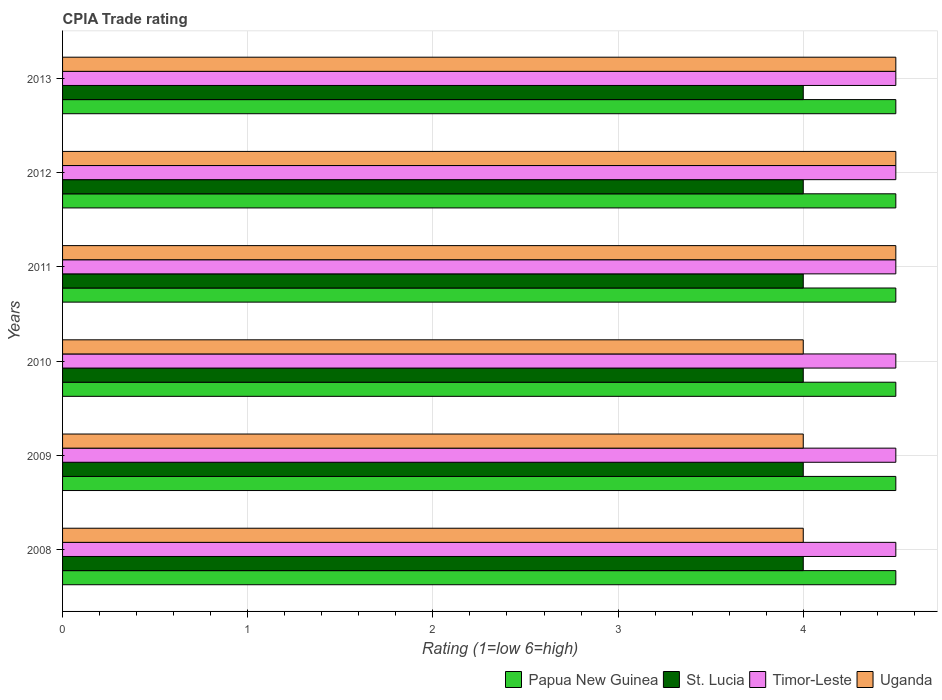How many groups of bars are there?
Give a very brief answer. 6. How many bars are there on the 3rd tick from the top?
Your answer should be very brief. 4. What is the CPIA rating in Papua New Guinea in 2012?
Provide a succinct answer. 4.5. Across all years, what is the maximum CPIA rating in Uganda?
Keep it short and to the point. 4.5. Across all years, what is the minimum CPIA rating in St. Lucia?
Make the answer very short. 4. In which year was the CPIA rating in Uganda maximum?
Provide a short and direct response. 2011. What is the total CPIA rating in St. Lucia in the graph?
Your answer should be very brief. 24. What is the difference between the CPIA rating in Uganda in 2010 and the CPIA rating in Timor-Leste in 2009?
Your answer should be compact. -0.5. What is the ratio of the CPIA rating in St. Lucia in 2011 to that in 2012?
Your response must be concise. 1. Is the CPIA rating in St. Lucia in 2010 less than that in 2011?
Ensure brevity in your answer.  No. Is the difference between the CPIA rating in St. Lucia in 2009 and 2011 greater than the difference between the CPIA rating in Timor-Leste in 2009 and 2011?
Provide a succinct answer. No. What is the difference between the highest and the second highest CPIA rating in St. Lucia?
Provide a short and direct response. 0. What is the difference between the highest and the lowest CPIA rating in Timor-Leste?
Ensure brevity in your answer.  0. Is it the case that in every year, the sum of the CPIA rating in Papua New Guinea and CPIA rating in Timor-Leste is greater than the sum of CPIA rating in Uganda and CPIA rating in St. Lucia?
Your answer should be compact. No. What does the 2nd bar from the top in 2011 represents?
Provide a short and direct response. Timor-Leste. What does the 2nd bar from the bottom in 2009 represents?
Your answer should be compact. St. Lucia. How many bars are there?
Offer a terse response. 24. What is the difference between two consecutive major ticks on the X-axis?
Provide a succinct answer. 1. Are the values on the major ticks of X-axis written in scientific E-notation?
Provide a succinct answer. No. Does the graph contain any zero values?
Your answer should be compact. No. Does the graph contain grids?
Your response must be concise. Yes. Where does the legend appear in the graph?
Keep it short and to the point. Bottom right. How many legend labels are there?
Keep it short and to the point. 4. How are the legend labels stacked?
Keep it short and to the point. Horizontal. What is the title of the graph?
Offer a very short reply. CPIA Trade rating. What is the Rating (1=low 6=high) in St. Lucia in 2008?
Make the answer very short. 4. What is the Rating (1=low 6=high) in Timor-Leste in 2008?
Provide a succinct answer. 4.5. What is the Rating (1=low 6=high) of Uganda in 2008?
Provide a short and direct response. 4. What is the Rating (1=low 6=high) in Timor-Leste in 2009?
Your response must be concise. 4.5. What is the Rating (1=low 6=high) in St. Lucia in 2010?
Your answer should be compact. 4. What is the Rating (1=low 6=high) in St. Lucia in 2011?
Your answer should be compact. 4. What is the Rating (1=low 6=high) in Uganda in 2011?
Give a very brief answer. 4.5. What is the Rating (1=low 6=high) of Papua New Guinea in 2013?
Offer a terse response. 4.5. What is the Rating (1=low 6=high) in Uganda in 2013?
Ensure brevity in your answer.  4.5. Across all years, what is the maximum Rating (1=low 6=high) in Papua New Guinea?
Your answer should be very brief. 4.5. Across all years, what is the maximum Rating (1=low 6=high) in St. Lucia?
Keep it short and to the point. 4. Across all years, what is the maximum Rating (1=low 6=high) of Uganda?
Ensure brevity in your answer.  4.5. Across all years, what is the minimum Rating (1=low 6=high) in Papua New Guinea?
Your answer should be very brief. 4.5. Across all years, what is the minimum Rating (1=low 6=high) in St. Lucia?
Your answer should be compact. 4. Across all years, what is the minimum Rating (1=low 6=high) in Uganda?
Your answer should be compact. 4. What is the total Rating (1=low 6=high) in Papua New Guinea in the graph?
Offer a very short reply. 27. What is the total Rating (1=low 6=high) of St. Lucia in the graph?
Make the answer very short. 24. What is the total Rating (1=low 6=high) of Timor-Leste in the graph?
Offer a terse response. 27. What is the difference between the Rating (1=low 6=high) in Papua New Guinea in 2008 and that in 2009?
Ensure brevity in your answer.  0. What is the difference between the Rating (1=low 6=high) in Timor-Leste in 2008 and that in 2009?
Make the answer very short. 0. What is the difference between the Rating (1=low 6=high) of Uganda in 2008 and that in 2009?
Your answer should be compact. 0. What is the difference between the Rating (1=low 6=high) in Timor-Leste in 2008 and that in 2010?
Give a very brief answer. 0. What is the difference between the Rating (1=low 6=high) of Uganda in 2008 and that in 2010?
Offer a very short reply. 0. What is the difference between the Rating (1=low 6=high) in Papua New Guinea in 2008 and that in 2011?
Offer a very short reply. 0. What is the difference between the Rating (1=low 6=high) of St. Lucia in 2008 and that in 2011?
Make the answer very short. 0. What is the difference between the Rating (1=low 6=high) in Uganda in 2008 and that in 2011?
Offer a very short reply. -0.5. What is the difference between the Rating (1=low 6=high) in Timor-Leste in 2008 and that in 2012?
Make the answer very short. 0. What is the difference between the Rating (1=low 6=high) of Uganda in 2008 and that in 2012?
Your answer should be compact. -0.5. What is the difference between the Rating (1=low 6=high) in Papua New Guinea in 2008 and that in 2013?
Provide a short and direct response. 0. What is the difference between the Rating (1=low 6=high) in St. Lucia in 2008 and that in 2013?
Offer a terse response. 0. What is the difference between the Rating (1=low 6=high) of Timor-Leste in 2008 and that in 2013?
Your answer should be compact. 0. What is the difference between the Rating (1=low 6=high) in Uganda in 2008 and that in 2013?
Provide a short and direct response. -0.5. What is the difference between the Rating (1=low 6=high) of Uganda in 2009 and that in 2010?
Offer a terse response. 0. What is the difference between the Rating (1=low 6=high) in Papua New Guinea in 2009 and that in 2012?
Keep it short and to the point. 0. What is the difference between the Rating (1=low 6=high) in St. Lucia in 2009 and that in 2012?
Keep it short and to the point. 0. What is the difference between the Rating (1=low 6=high) in Timor-Leste in 2009 and that in 2012?
Offer a terse response. 0. What is the difference between the Rating (1=low 6=high) of Uganda in 2009 and that in 2012?
Make the answer very short. -0.5. What is the difference between the Rating (1=low 6=high) in Papua New Guinea in 2009 and that in 2013?
Provide a short and direct response. 0. What is the difference between the Rating (1=low 6=high) of St. Lucia in 2009 and that in 2013?
Provide a short and direct response. 0. What is the difference between the Rating (1=low 6=high) of Timor-Leste in 2009 and that in 2013?
Provide a short and direct response. 0. What is the difference between the Rating (1=low 6=high) of Papua New Guinea in 2010 and that in 2011?
Ensure brevity in your answer.  0. What is the difference between the Rating (1=low 6=high) in Uganda in 2010 and that in 2012?
Your response must be concise. -0.5. What is the difference between the Rating (1=low 6=high) in St. Lucia in 2010 and that in 2013?
Your answer should be compact. 0. What is the difference between the Rating (1=low 6=high) in Uganda in 2010 and that in 2013?
Your answer should be compact. -0.5. What is the difference between the Rating (1=low 6=high) in Papua New Guinea in 2011 and that in 2012?
Your answer should be compact. 0. What is the difference between the Rating (1=low 6=high) of Timor-Leste in 2011 and that in 2012?
Make the answer very short. 0. What is the difference between the Rating (1=low 6=high) of Uganda in 2011 and that in 2012?
Ensure brevity in your answer.  0. What is the difference between the Rating (1=low 6=high) of St. Lucia in 2011 and that in 2013?
Provide a succinct answer. 0. What is the difference between the Rating (1=low 6=high) of Timor-Leste in 2011 and that in 2013?
Your response must be concise. 0. What is the difference between the Rating (1=low 6=high) of Uganda in 2011 and that in 2013?
Provide a succinct answer. 0. What is the difference between the Rating (1=low 6=high) in Timor-Leste in 2012 and that in 2013?
Offer a terse response. 0. What is the difference between the Rating (1=low 6=high) in Uganda in 2012 and that in 2013?
Your answer should be very brief. 0. What is the difference between the Rating (1=low 6=high) of Papua New Guinea in 2008 and the Rating (1=low 6=high) of Timor-Leste in 2009?
Give a very brief answer. 0. What is the difference between the Rating (1=low 6=high) of Papua New Guinea in 2008 and the Rating (1=low 6=high) of Uganda in 2009?
Provide a short and direct response. 0.5. What is the difference between the Rating (1=low 6=high) of St. Lucia in 2008 and the Rating (1=low 6=high) of Uganda in 2009?
Offer a very short reply. 0. What is the difference between the Rating (1=low 6=high) of Timor-Leste in 2008 and the Rating (1=low 6=high) of Uganda in 2009?
Offer a terse response. 0.5. What is the difference between the Rating (1=low 6=high) of Papua New Guinea in 2008 and the Rating (1=low 6=high) of Timor-Leste in 2010?
Offer a terse response. 0. What is the difference between the Rating (1=low 6=high) in Papua New Guinea in 2008 and the Rating (1=low 6=high) in Uganda in 2010?
Ensure brevity in your answer.  0.5. What is the difference between the Rating (1=low 6=high) in St. Lucia in 2008 and the Rating (1=low 6=high) in Uganda in 2010?
Your answer should be compact. 0. What is the difference between the Rating (1=low 6=high) of Papua New Guinea in 2008 and the Rating (1=low 6=high) of Uganda in 2011?
Give a very brief answer. 0. What is the difference between the Rating (1=low 6=high) of St. Lucia in 2008 and the Rating (1=low 6=high) of Timor-Leste in 2011?
Give a very brief answer. -0.5. What is the difference between the Rating (1=low 6=high) in St. Lucia in 2008 and the Rating (1=low 6=high) in Uganda in 2011?
Provide a short and direct response. -0.5. What is the difference between the Rating (1=low 6=high) in Papua New Guinea in 2008 and the Rating (1=low 6=high) in Timor-Leste in 2012?
Keep it short and to the point. 0. What is the difference between the Rating (1=low 6=high) in St. Lucia in 2008 and the Rating (1=low 6=high) in Timor-Leste in 2012?
Offer a very short reply. -0.5. What is the difference between the Rating (1=low 6=high) of Papua New Guinea in 2008 and the Rating (1=low 6=high) of St. Lucia in 2013?
Keep it short and to the point. 0.5. What is the difference between the Rating (1=low 6=high) of St. Lucia in 2008 and the Rating (1=low 6=high) of Timor-Leste in 2013?
Your answer should be compact. -0.5. What is the difference between the Rating (1=low 6=high) in Timor-Leste in 2008 and the Rating (1=low 6=high) in Uganda in 2013?
Your answer should be compact. 0. What is the difference between the Rating (1=low 6=high) of Papua New Guinea in 2009 and the Rating (1=low 6=high) of Timor-Leste in 2010?
Provide a succinct answer. 0. What is the difference between the Rating (1=low 6=high) in Papua New Guinea in 2009 and the Rating (1=low 6=high) in Uganda in 2010?
Offer a very short reply. 0.5. What is the difference between the Rating (1=low 6=high) of St. Lucia in 2009 and the Rating (1=low 6=high) of Timor-Leste in 2010?
Your answer should be compact. -0.5. What is the difference between the Rating (1=low 6=high) in St. Lucia in 2009 and the Rating (1=low 6=high) in Uganda in 2010?
Offer a terse response. 0. What is the difference between the Rating (1=low 6=high) in Timor-Leste in 2009 and the Rating (1=low 6=high) in Uganda in 2010?
Your response must be concise. 0.5. What is the difference between the Rating (1=low 6=high) of Papua New Guinea in 2009 and the Rating (1=low 6=high) of Timor-Leste in 2011?
Offer a terse response. 0. What is the difference between the Rating (1=low 6=high) of St. Lucia in 2009 and the Rating (1=low 6=high) of Timor-Leste in 2011?
Offer a very short reply. -0.5. What is the difference between the Rating (1=low 6=high) in St. Lucia in 2009 and the Rating (1=low 6=high) in Uganda in 2011?
Provide a short and direct response. -0.5. What is the difference between the Rating (1=low 6=high) of Timor-Leste in 2009 and the Rating (1=low 6=high) of Uganda in 2011?
Provide a short and direct response. 0. What is the difference between the Rating (1=low 6=high) of Papua New Guinea in 2009 and the Rating (1=low 6=high) of St. Lucia in 2012?
Offer a terse response. 0.5. What is the difference between the Rating (1=low 6=high) of Papua New Guinea in 2009 and the Rating (1=low 6=high) of Uganda in 2012?
Give a very brief answer. 0. What is the difference between the Rating (1=low 6=high) in Timor-Leste in 2009 and the Rating (1=low 6=high) in Uganda in 2012?
Provide a succinct answer. 0. What is the difference between the Rating (1=low 6=high) in Papua New Guinea in 2009 and the Rating (1=low 6=high) in Timor-Leste in 2013?
Provide a short and direct response. 0. What is the difference between the Rating (1=low 6=high) in Papua New Guinea in 2009 and the Rating (1=low 6=high) in Uganda in 2013?
Make the answer very short. 0. What is the difference between the Rating (1=low 6=high) of St. Lucia in 2009 and the Rating (1=low 6=high) of Timor-Leste in 2013?
Provide a succinct answer. -0.5. What is the difference between the Rating (1=low 6=high) of Papua New Guinea in 2010 and the Rating (1=low 6=high) of St. Lucia in 2011?
Keep it short and to the point. 0.5. What is the difference between the Rating (1=low 6=high) of St. Lucia in 2010 and the Rating (1=low 6=high) of Uganda in 2011?
Offer a terse response. -0.5. What is the difference between the Rating (1=low 6=high) of Timor-Leste in 2010 and the Rating (1=low 6=high) of Uganda in 2011?
Ensure brevity in your answer.  0. What is the difference between the Rating (1=low 6=high) in Papua New Guinea in 2010 and the Rating (1=low 6=high) in Timor-Leste in 2012?
Your response must be concise. 0. What is the difference between the Rating (1=low 6=high) of Papua New Guinea in 2010 and the Rating (1=low 6=high) of Uganda in 2012?
Your response must be concise. 0. What is the difference between the Rating (1=low 6=high) in St. Lucia in 2010 and the Rating (1=low 6=high) in Timor-Leste in 2012?
Your response must be concise. -0.5. What is the difference between the Rating (1=low 6=high) of Timor-Leste in 2010 and the Rating (1=low 6=high) of Uganda in 2012?
Offer a terse response. 0. What is the difference between the Rating (1=low 6=high) of Papua New Guinea in 2010 and the Rating (1=low 6=high) of Timor-Leste in 2013?
Your response must be concise. 0. What is the difference between the Rating (1=low 6=high) in Papua New Guinea in 2010 and the Rating (1=low 6=high) in Uganda in 2013?
Offer a terse response. 0. What is the difference between the Rating (1=low 6=high) in Timor-Leste in 2010 and the Rating (1=low 6=high) in Uganda in 2013?
Your answer should be compact. 0. What is the difference between the Rating (1=low 6=high) of Papua New Guinea in 2011 and the Rating (1=low 6=high) of Timor-Leste in 2012?
Your answer should be very brief. 0. What is the difference between the Rating (1=low 6=high) in Papua New Guinea in 2011 and the Rating (1=low 6=high) in Uganda in 2012?
Keep it short and to the point. 0. What is the difference between the Rating (1=low 6=high) of St. Lucia in 2011 and the Rating (1=low 6=high) of Timor-Leste in 2012?
Offer a very short reply. -0.5. What is the difference between the Rating (1=low 6=high) in Papua New Guinea in 2011 and the Rating (1=low 6=high) in Timor-Leste in 2013?
Give a very brief answer. 0. What is the difference between the Rating (1=low 6=high) in St. Lucia in 2011 and the Rating (1=low 6=high) in Timor-Leste in 2013?
Offer a terse response. -0.5. What is the difference between the Rating (1=low 6=high) in Timor-Leste in 2011 and the Rating (1=low 6=high) in Uganda in 2013?
Your answer should be very brief. 0. What is the difference between the Rating (1=low 6=high) of Papua New Guinea in 2012 and the Rating (1=low 6=high) of St. Lucia in 2013?
Your answer should be very brief. 0.5. What is the average Rating (1=low 6=high) in St. Lucia per year?
Your response must be concise. 4. What is the average Rating (1=low 6=high) in Timor-Leste per year?
Offer a very short reply. 4.5. What is the average Rating (1=low 6=high) in Uganda per year?
Your response must be concise. 4.25. In the year 2008, what is the difference between the Rating (1=low 6=high) in Papua New Guinea and Rating (1=low 6=high) in St. Lucia?
Your answer should be compact. 0.5. In the year 2008, what is the difference between the Rating (1=low 6=high) of Papua New Guinea and Rating (1=low 6=high) of Uganda?
Keep it short and to the point. 0.5. In the year 2008, what is the difference between the Rating (1=low 6=high) in St. Lucia and Rating (1=low 6=high) in Timor-Leste?
Provide a short and direct response. -0.5. In the year 2008, what is the difference between the Rating (1=low 6=high) in Timor-Leste and Rating (1=low 6=high) in Uganda?
Provide a succinct answer. 0.5. In the year 2009, what is the difference between the Rating (1=low 6=high) in Papua New Guinea and Rating (1=low 6=high) in St. Lucia?
Provide a short and direct response. 0.5. In the year 2009, what is the difference between the Rating (1=low 6=high) in Papua New Guinea and Rating (1=low 6=high) in Timor-Leste?
Offer a very short reply. 0. In the year 2009, what is the difference between the Rating (1=low 6=high) in Timor-Leste and Rating (1=low 6=high) in Uganda?
Ensure brevity in your answer.  0.5. In the year 2010, what is the difference between the Rating (1=low 6=high) in Papua New Guinea and Rating (1=low 6=high) in Uganda?
Provide a succinct answer. 0.5. In the year 2010, what is the difference between the Rating (1=low 6=high) in St. Lucia and Rating (1=low 6=high) in Timor-Leste?
Offer a terse response. -0.5. In the year 2010, what is the difference between the Rating (1=low 6=high) of Timor-Leste and Rating (1=low 6=high) of Uganda?
Make the answer very short. 0.5. In the year 2011, what is the difference between the Rating (1=low 6=high) of Papua New Guinea and Rating (1=low 6=high) of Uganda?
Keep it short and to the point. 0. In the year 2011, what is the difference between the Rating (1=low 6=high) of Timor-Leste and Rating (1=low 6=high) of Uganda?
Provide a succinct answer. 0. In the year 2012, what is the difference between the Rating (1=low 6=high) in St. Lucia and Rating (1=low 6=high) in Timor-Leste?
Provide a short and direct response. -0.5. In the year 2012, what is the difference between the Rating (1=low 6=high) in Timor-Leste and Rating (1=low 6=high) in Uganda?
Your answer should be compact. 0. In the year 2013, what is the difference between the Rating (1=low 6=high) in Papua New Guinea and Rating (1=low 6=high) in Timor-Leste?
Your response must be concise. 0. In the year 2013, what is the difference between the Rating (1=low 6=high) in Papua New Guinea and Rating (1=low 6=high) in Uganda?
Offer a very short reply. 0. What is the ratio of the Rating (1=low 6=high) in Papua New Guinea in 2008 to that in 2009?
Give a very brief answer. 1. What is the ratio of the Rating (1=low 6=high) of St. Lucia in 2008 to that in 2009?
Make the answer very short. 1. What is the ratio of the Rating (1=low 6=high) of Uganda in 2008 to that in 2009?
Provide a short and direct response. 1. What is the ratio of the Rating (1=low 6=high) of St. Lucia in 2008 to that in 2010?
Give a very brief answer. 1. What is the ratio of the Rating (1=low 6=high) in Uganda in 2008 to that in 2011?
Provide a short and direct response. 0.89. What is the ratio of the Rating (1=low 6=high) of Papua New Guinea in 2008 to that in 2012?
Ensure brevity in your answer.  1. What is the ratio of the Rating (1=low 6=high) in Timor-Leste in 2008 to that in 2012?
Offer a very short reply. 1. What is the ratio of the Rating (1=low 6=high) of Papua New Guinea in 2008 to that in 2013?
Provide a succinct answer. 1. What is the ratio of the Rating (1=low 6=high) in St. Lucia in 2009 to that in 2010?
Your response must be concise. 1. What is the ratio of the Rating (1=low 6=high) in Uganda in 2009 to that in 2010?
Offer a terse response. 1. What is the ratio of the Rating (1=low 6=high) in Timor-Leste in 2009 to that in 2011?
Your response must be concise. 1. What is the ratio of the Rating (1=low 6=high) of Papua New Guinea in 2009 to that in 2012?
Give a very brief answer. 1. What is the ratio of the Rating (1=low 6=high) in Timor-Leste in 2009 to that in 2012?
Provide a short and direct response. 1. What is the ratio of the Rating (1=low 6=high) of Uganda in 2009 to that in 2012?
Keep it short and to the point. 0.89. What is the ratio of the Rating (1=low 6=high) of Papua New Guinea in 2009 to that in 2013?
Offer a very short reply. 1. What is the ratio of the Rating (1=low 6=high) of Uganda in 2009 to that in 2013?
Give a very brief answer. 0.89. What is the ratio of the Rating (1=low 6=high) in Papua New Guinea in 2010 to that in 2011?
Your response must be concise. 1. What is the ratio of the Rating (1=low 6=high) of Timor-Leste in 2010 to that in 2011?
Your answer should be very brief. 1. What is the ratio of the Rating (1=low 6=high) of Papua New Guinea in 2010 to that in 2012?
Offer a terse response. 1. What is the ratio of the Rating (1=low 6=high) in St. Lucia in 2010 to that in 2012?
Make the answer very short. 1. What is the ratio of the Rating (1=low 6=high) in Uganda in 2010 to that in 2012?
Make the answer very short. 0.89. What is the ratio of the Rating (1=low 6=high) in Papua New Guinea in 2010 to that in 2013?
Provide a short and direct response. 1. What is the ratio of the Rating (1=low 6=high) in Timor-Leste in 2010 to that in 2013?
Your response must be concise. 1. What is the ratio of the Rating (1=low 6=high) of Uganda in 2010 to that in 2013?
Offer a very short reply. 0.89. What is the ratio of the Rating (1=low 6=high) in Papua New Guinea in 2011 to that in 2012?
Give a very brief answer. 1. What is the ratio of the Rating (1=low 6=high) in Uganda in 2011 to that in 2012?
Give a very brief answer. 1. What is the ratio of the Rating (1=low 6=high) in Papua New Guinea in 2011 to that in 2013?
Provide a succinct answer. 1. What is the ratio of the Rating (1=low 6=high) in Uganda in 2011 to that in 2013?
Offer a very short reply. 1. What is the ratio of the Rating (1=low 6=high) of Papua New Guinea in 2012 to that in 2013?
Provide a short and direct response. 1. What is the ratio of the Rating (1=low 6=high) in St. Lucia in 2012 to that in 2013?
Provide a short and direct response. 1. What is the ratio of the Rating (1=low 6=high) of Uganda in 2012 to that in 2013?
Provide a succinct answer. 1. What is the difference between the highest and the second highest Rating (1=low 6=high) of Papua New Guinea?
Ensure brevity in your answer.  0. What is the difference between the highest and the second highest Rating (1=low 6=high) in St. Lucia?
Ensure brevity in your answer.  0. What is the difference between the highest and the lowest Rating (1=low 6=high) in Timor-Leste?
Provide a short and direct response. 0. 